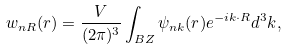<formula> <loc_0><loc_0><loc_500><loc_500>w _ { n { R } } ( { r } ) = \frac { V } { ( 2 \pi ) ^ { 3 } } \int _ { B Z } \psi _ { n { k } } ( { r } ) e ^ { - i { k } \cdot { R } } d ^ { 3 } k ,</formula> 